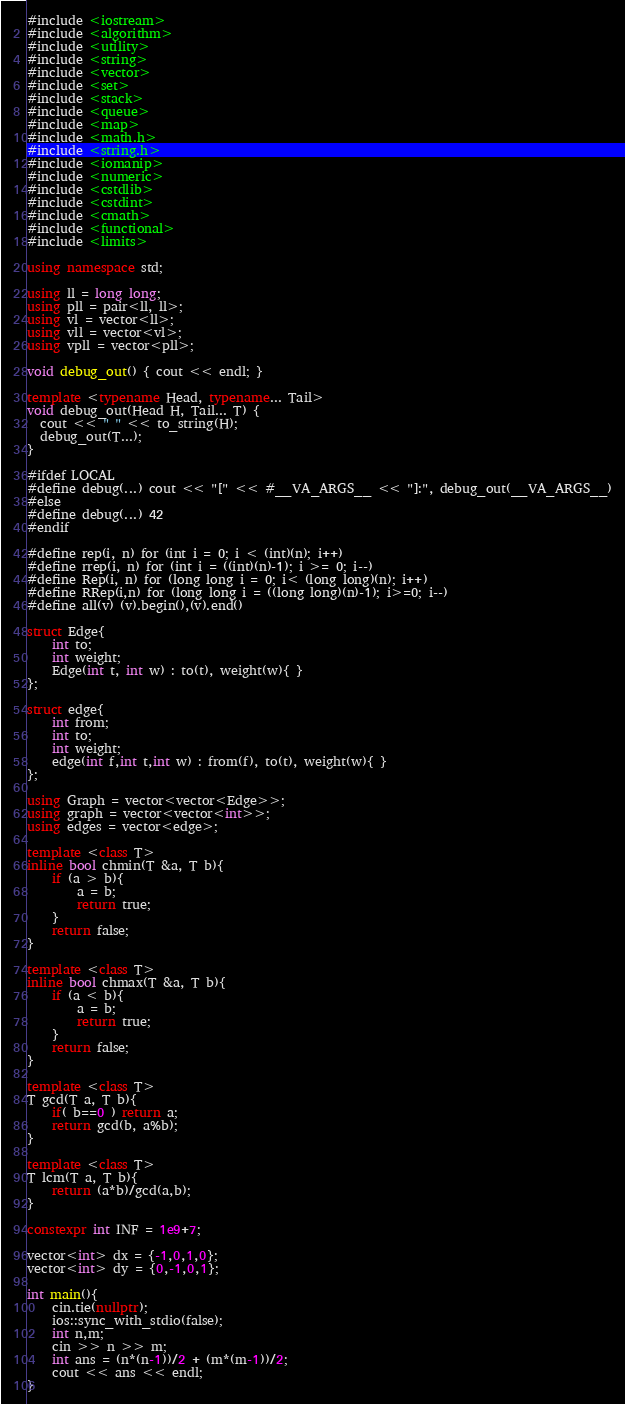Convert code to text. <code><loc_0><loc_0><loc_500><loc_500><_C++_>#include <iostream>
#include <algorithm>
#include <utility>
#include <string>
#include <vector>
#include <set>
#include <stack>
#include <queue>
#include <map>
#include <math.h>
#include <string.h>
#include <iomanip>
#include <numeric>
#include <cstdlib>
#include <cstdint>
#include <cmath>
#include <functional>
#include <limits>

using namespace std;

using ll = long long;
using pll = pair<ll, ll>;
using vl = vector<ll>;
using vll = vector<vl>;
using vpll = vector<pll>;

void debug_out() { cout << endl; }
 
template <typename Head, typename... Tail>
void debug_out(Head H, Tail... T) {
  cout << " " << to_string(H);
  debug_out(T...);
}

#ifdef LOCAL
#define debug(...) cout << "[" << #__VA_ARGS__ << "]:", debug_out(__VA_ARGS__)
#else
#define debug(...) 42
#endif

#define rep(i, n) for (int i = 0; i < (int)(n); i++)
#define rrep(i, n) for (int i = ((int)(n)-1); i >= 0; i--)
#define Rep(i, n) for (long long i = 0; i< (long long)(n); i++)
#define RRep(i,n) for (long long i = ((long long)(n)-1); i>=0; i--)
#define all(v) (v).begin(),(v).end()

struct Edge{
    int to;
    int weight;
    Edge(int t, int w) : to(t), weight(w){ }
};

struct edge{
    int from;
    int to;
    int weight;
    edge(int f,int t,int w) : from(f), to(t), weight(w){ }
};

using Graph = vector<vector<Edge>>;
using graph = vector<vector<int>>;
using edges = vector<edge>;

template <class T>
inline bool chmin(T &a, T b){
    if (a > b){
        a = b;
        return true;
    }
    return false;
}

template <class T>
inline bool chmax(T &a, T b){
    if (a < b){
        a = b;
        return true;
    }
    return false;
}

template <class T>
T gcd(T a, T b){
    if( b==0 ) return a;
    return gcd(b, a%b);
}

template <class T>
T lcm(T a, T b){
    return (a*b)/gcd(a,b);
}

constexpr int INF = 1e9+7;

vector<int> dx = {-1,0,1,0};
vector<int> dy = {0,-1,0,1};

int main(){
    cin.tie(nullptr);
    ios::sync_with_stdio(false);
    int n,m;
    cin >> n >> m;
    int ans = (n*(n-1))/2 + (m*(m-1))/2;
    cout << ans << endl;
}</code> 